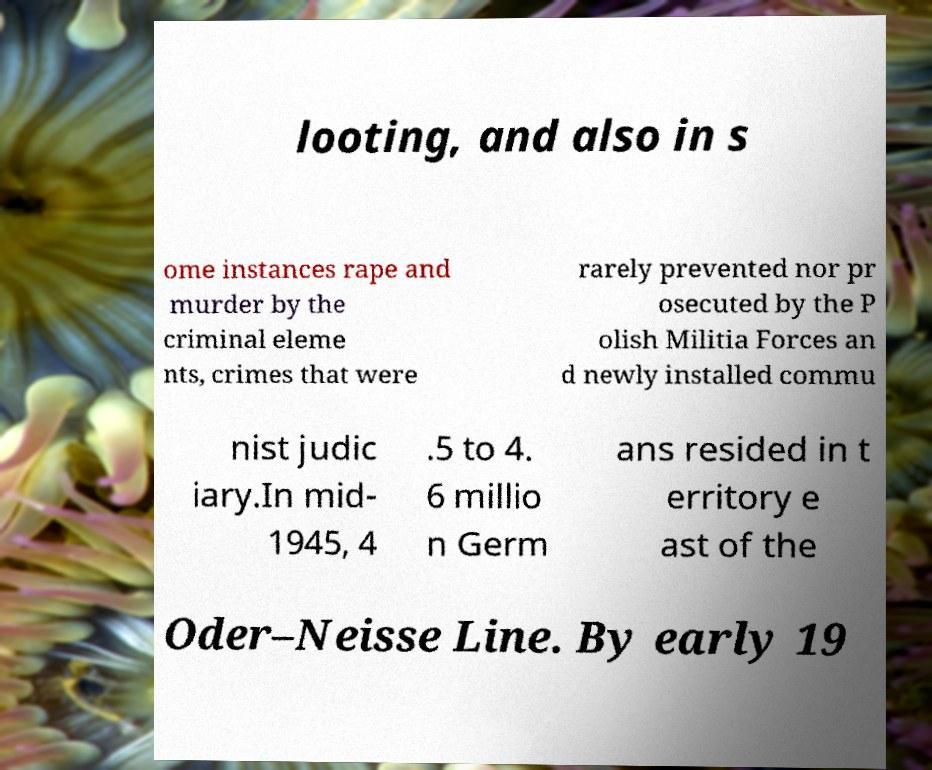I need the written content from this picture converted into text. Can you do that? looting, and also in s ome instances rape and murder by the criminal eleme nts, crimes that were rarely prevented nor pr osecuted by the P olish Militia Forces an d newly installed commu nist judic iary.In mid- 1945, 4 .5 to 4. 6 millio n Germ ans resided in t erritory e ast of the Oder–Neisse Line. By early 19 